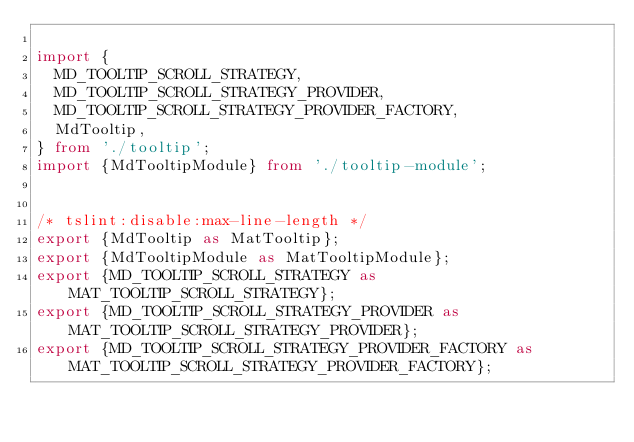<code> <loc_0><loc_0><loc_500><loc_500><_TypeScript_>
import {
  MD_TOOLTIP_SCROLL_STRATEGY,
  MD_TOOLTIP_SCROLL_STRATEGY_PROVIDER,
  MD_TOOLTIP_SCROLL_STRATEGY_PROVIDER_FACTORY,
  MdTooltip,
} from './tooltip';
import {MdTooltipModule} from './tooltip-module';


/* tslint:disable:max-line-length */
export {MdTooltip as MatTooltip};
export {MdTooltipModule as MatTooltipModule};
export {MD_TOOLTIP_SCROLL_STRATEGY as MAT_TOOLTIP_SCROLL_STRATEGY};
export {MD_TOOLTIP_SCROLL_STRATEGY_PROVIDER as MAT_TOOLTIP_SCROLL_STRATEGY_PROVIDER};
export {MD_TOOLTIP_SCROLL_STRATEGY_PROVIDER_FACTORY as MAT_TOOLTIP_SCROLL_STRATEGY_PROVIDER_FACTORY};
</code> 